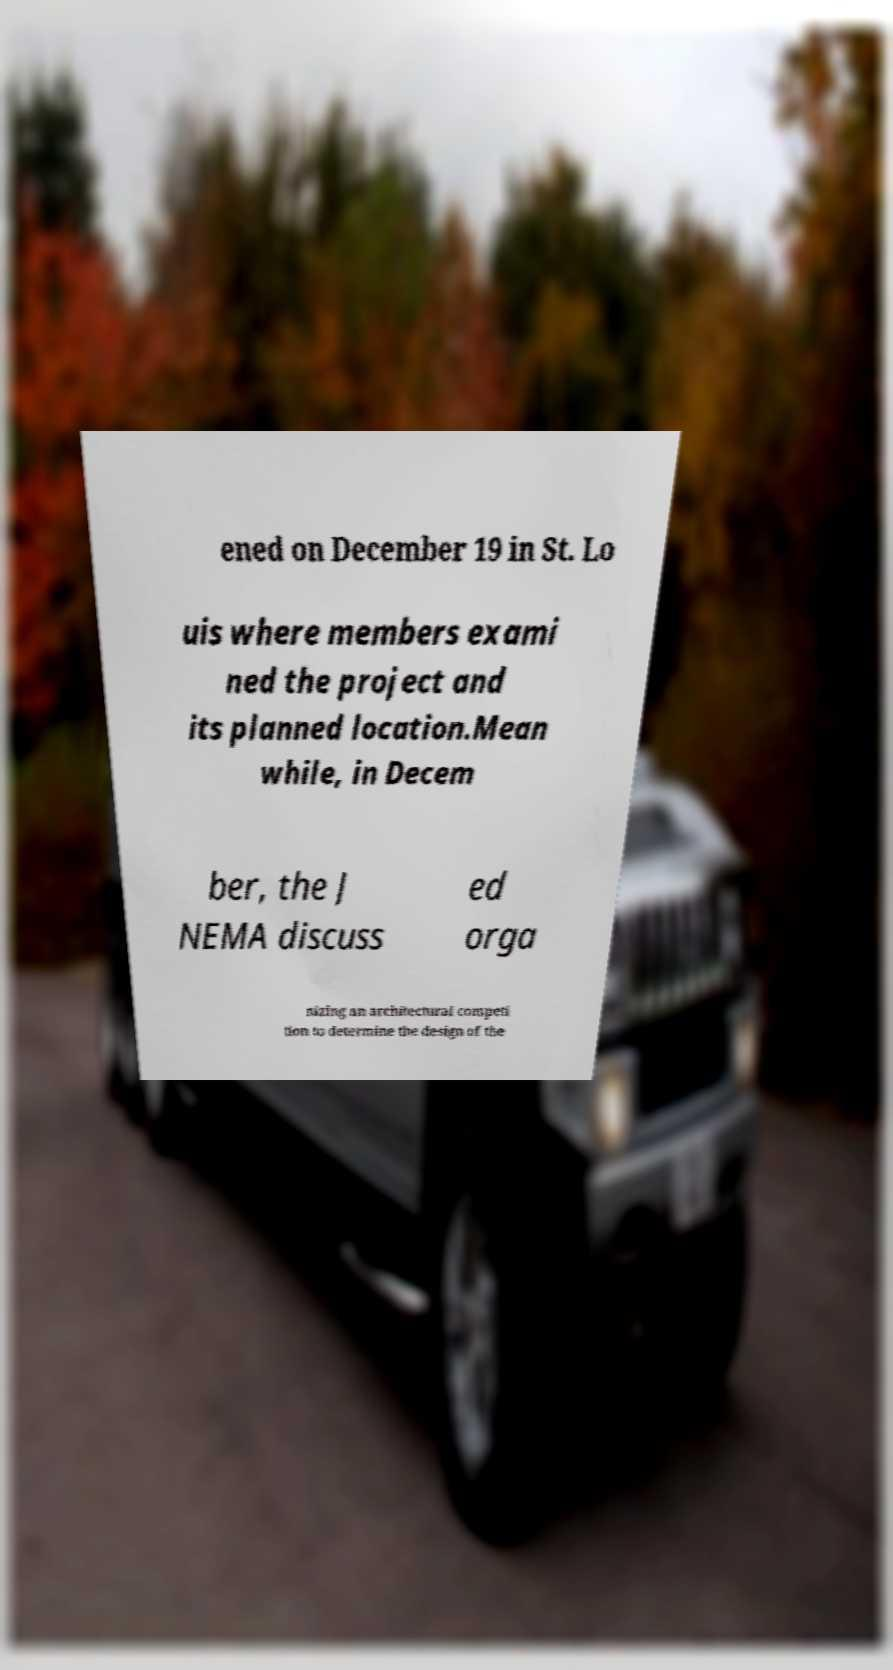I need the written content from this picture converted into text. Can you do that? ened on December 19 in St. Lo uis where members exami ned the project and its planned location.Mean while, in Decem ber, the J NEMA discuss ed orga nizing an architectural competi tion to determine the design of the 